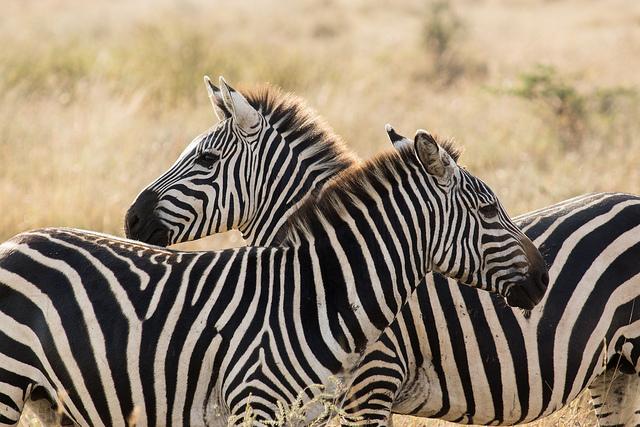How many zebras are in this picture?
Give a very brief answer. 2. Are the zebras in a zoo?
Quick response, please. No. Are these animals in their natural habitat?
Give a very brief answer. Yes. Are these zebras facing the same direction?
Write a very short answer. No. 